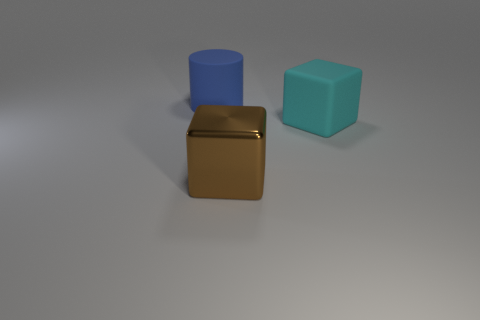How many objects are either matte things that are right of the metallic cube or large cylinders?
Your response must be concise. 2. The blue cylinder that is the same material as the big cyan thing is what size?
Offer a very short reply. Large. There is a brown shiny block; is it the same size as the rubber thing that is in front of the big blue matte object?
Your answer should be very brief. Yes. The large object that is behind the big shiny block and to the left of the cyan matte block is what color?
Provide a succinct answer. Blue. How many things are either matte objects that are in front of the blue rubber object or large rubber objects on the right side of the metal cube?
Your response must be concise. 1. There is a rubber object that is behind the large rubber object in front of the large blue thing on the left side of the brown shiny object; what color is it?
Offer a terse response. Blue. Is there another cyan object of the same shape as the metallic thing?
Offer a terse response. Yes. What number of matte cubes are there?
Your answer should be compact. 1. What is the shape of the blue matte thing?
Make the answer very short. Cylinder. How many gray metallic balls are the same size as the cyan cube?
Offer a terse response. 0. 